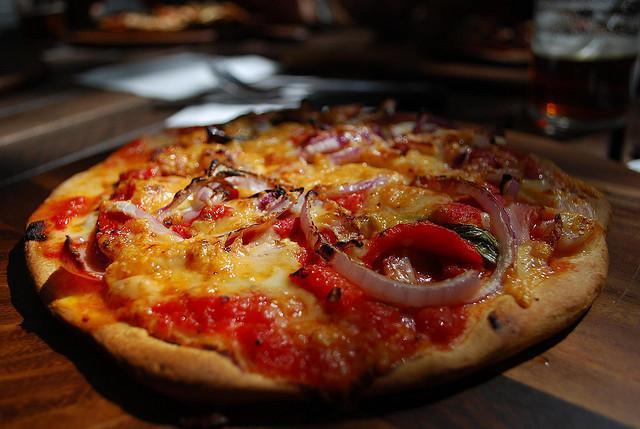How many dining tables can be seen?
Give a very brief answer. 2. 